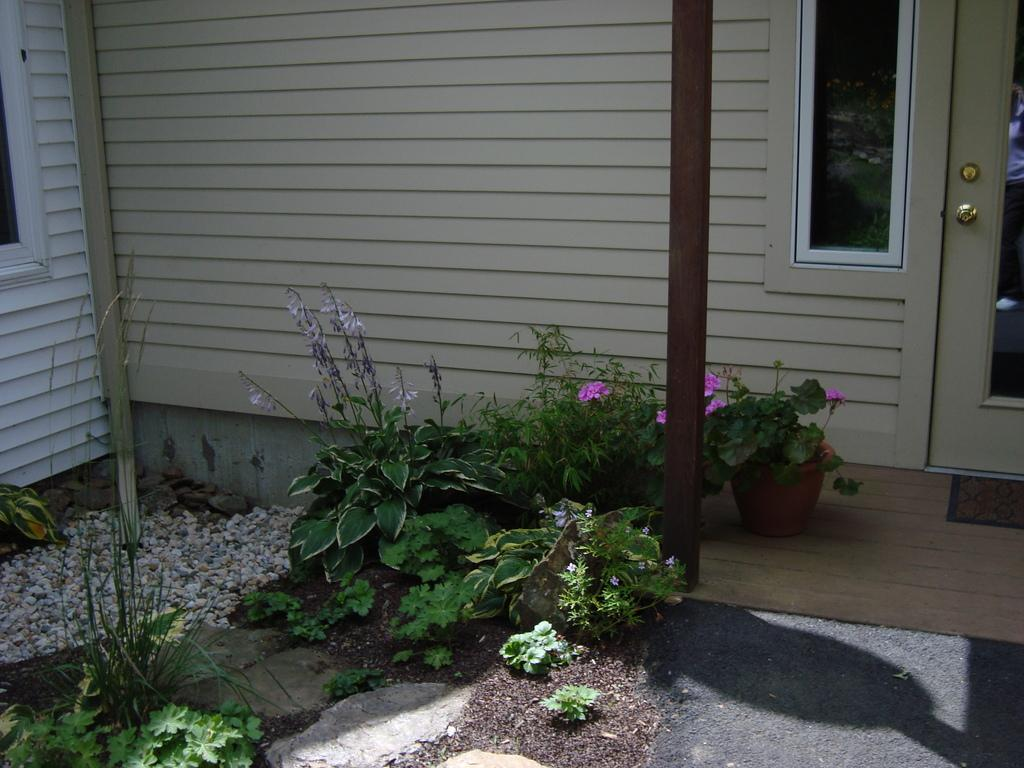What architectural element can be seen in the background of the image? There is a partial part of a door visible in the background. What type of window is present in the image? There is a glass window in the image. What type of surface is visible in the image? There is a wall in the image. What type of fastener is present in the image? There is a bolt in the image. What type of vegetation is present in the image? There are plants in the image. What type of container is present in the image? There is a pot in the image. What type of vertical support is present in the image? There is a pole in the image. What type of floor covering is present in the image? There is a door mat in the image. What type of small, rounded stones are present in the image? There are pebbles in the image. What type of animal is the representative of the plants in the image? There is no animal or representative for the plants in the image. 